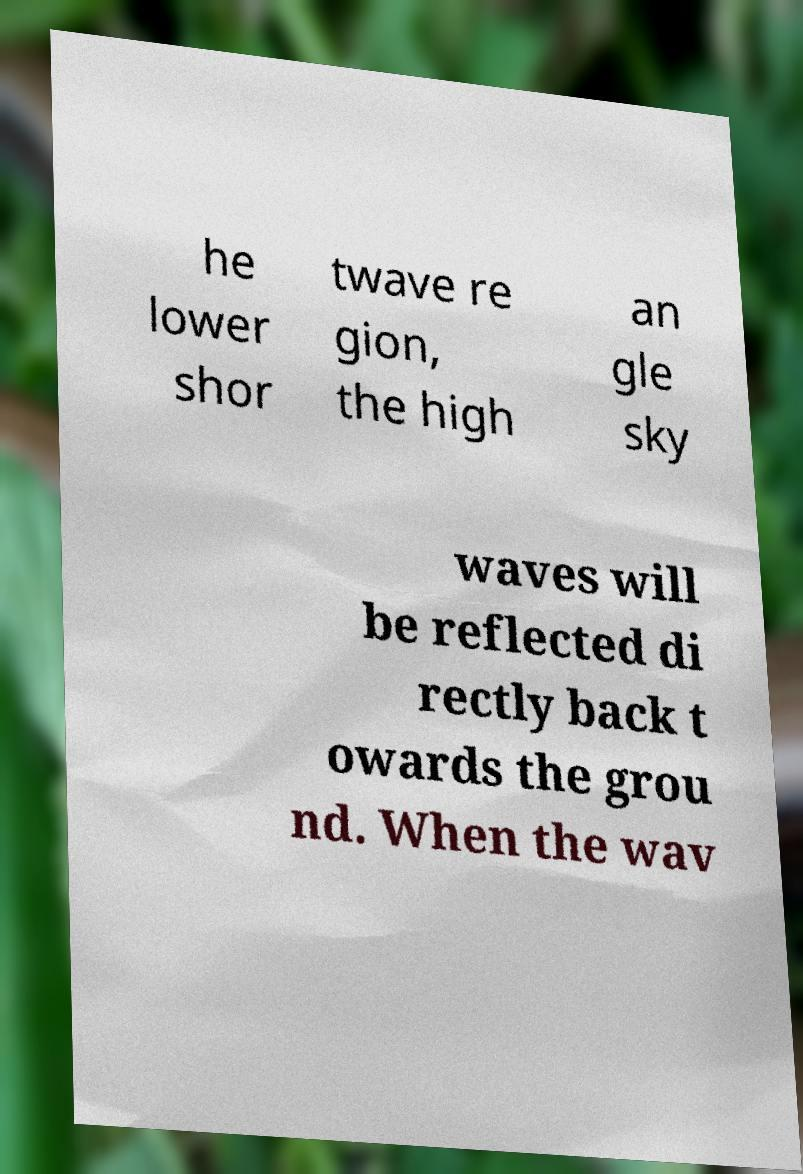There's text embedded in this image that I need extracted. Can you transcribe it verbatim? he lower shor twave re gion, the high an gle sky waves will be reflected di rectly back t owards the grou nd. When the wav 